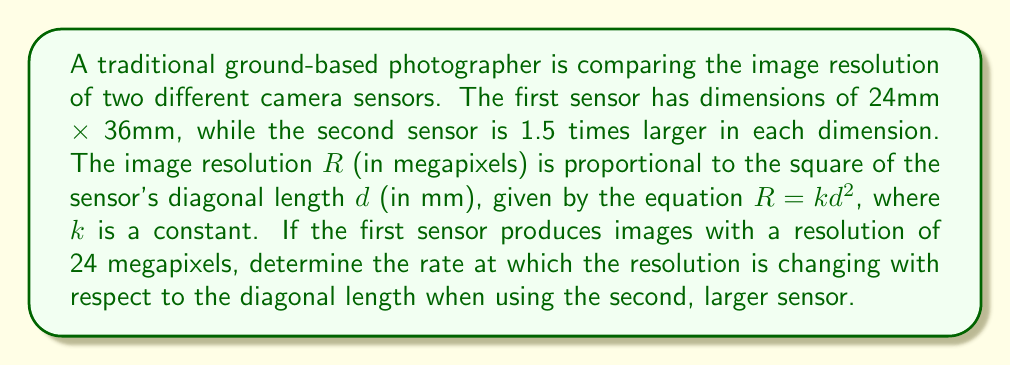Teach me how to tackle this problem. Let's approach this step-by-step:

1) First, we need to find the diagonal length of the first sensor:
   $$d_1 = \sqrt{24^2 + 36^2} = \sqrt{1872} = 12\sqrt{13} \text{ mm}$$

2) Now, we can find the constant $k$ using the given information for the first sensor:
   $$24 = k(12\sqrt{13})^2$$
   $$24 = 1872k$$
   $$k = \frac{1}{78}$$

3) For the second sensor, each dimension is 1.5 times larger:
   $$d_2 = 1.5 \cdot 12\sqrt{13} = 18\sqrt{13} \text{ mm}$$

4) The equation for resolution as a function of diagonal length is:
   $$R = \frac{1}{78}d^2$$

5) To find the rate of change of resolution with respect to diagonal length, we need to differentiate this equation:
   $$\frac{dR}{dd} = \frac{2}{78}d$$

6) Now, we can evaluate this at the diagonal length of the second sensor:
   $$\left.\frac{dR}{dd}\right|_{d=18\sqrt{13}} = \frac{2}{78}(18\sqrt{13}) = \frac{36\sqrt{13}}{78} = \frac{6\sqrt{13}}{13}$$

This gives us the rate of change in megapixels per mm at the diagonal length of the larger sensor.
Answer: The rate at which the resolution is changing with respect to the diagonal length when using the larger sensor is $\frac{6\sqrt{13}}{13}$ megapixels per mm. 